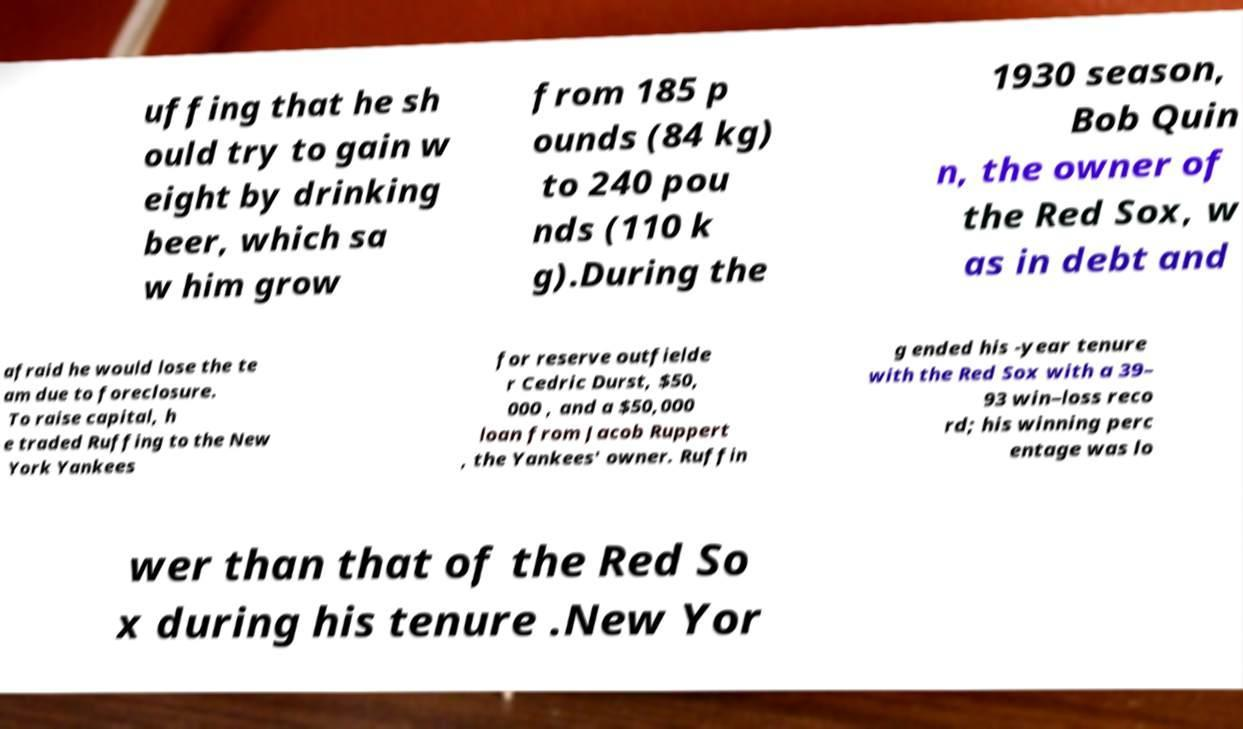Can you read and provide the text displayed in the image?This photo seems to have some interesting text. Can you extract and type it out for me? uffing that he sh ould try to gain w eight by drinking beer, which sa w him grow from 185 p ounds (84 kg) to 240 pou nds (110 k g).During the 1930 season, Bob Quin n, the owner of the Red Sox, w as in debt and afraid he would lose the te am due to foreclosure. To raise capital, h e traded Ruffing to the New York Yankees for reserve outfielde r Cedric Durst, $50, 000 , and a $50,000 loan from Jacob Ruppert , the Yankees' owner. Ruffin g ended his -year tenure with the Red Sox with a 39– 93 win–loss reco rd; his winning perc entage was lo wer than that of the Red So x during his tenure .New Yor 